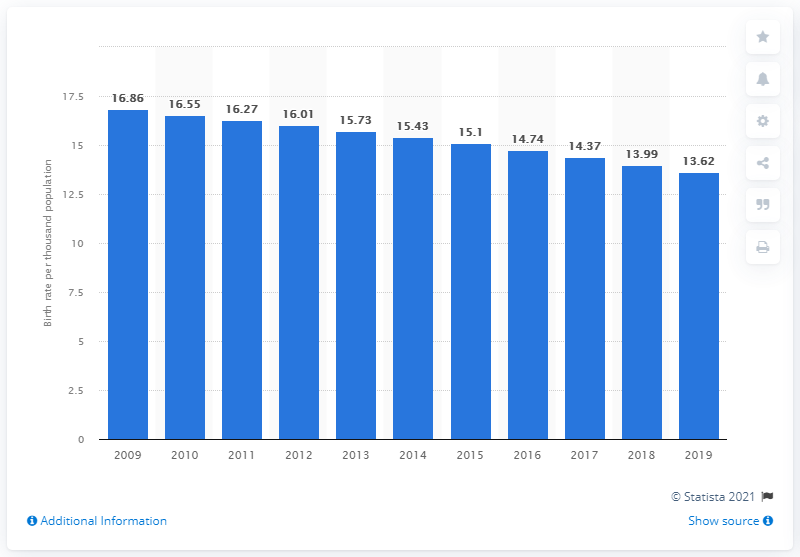Give some essential details in this illustration. In 2019, the crude birth rate in Bahrain was 13.62. 